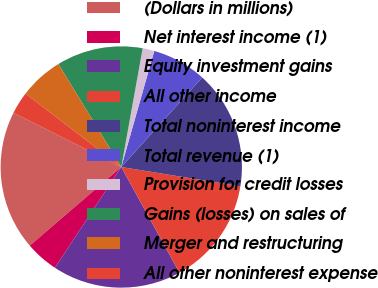Convert chart. <chart><loc_0><loc_0><loc_500><loc_500><pie_chart><fcel>(Dollars in millions)<fcel>Net interest income (1)<fcel>Equity investment gains<fcel>All other income<fcel>Total noninterest income<fcel>Total revenue (1)<fcel>Provision for credit losses<fcel>Gains (losses) on sales of<fcel>Merger and restructuring<fcel>All other noninterest expense<nl><fcel>18.71%<fcel>4.43%<fcel>17.28%<fcel>14.43%<fcel>15.86%<fcel>7.29%<fcel>1.57%<fcel>11.57%<fcel>5.86%<fcel>3.0%<nl></chart> 